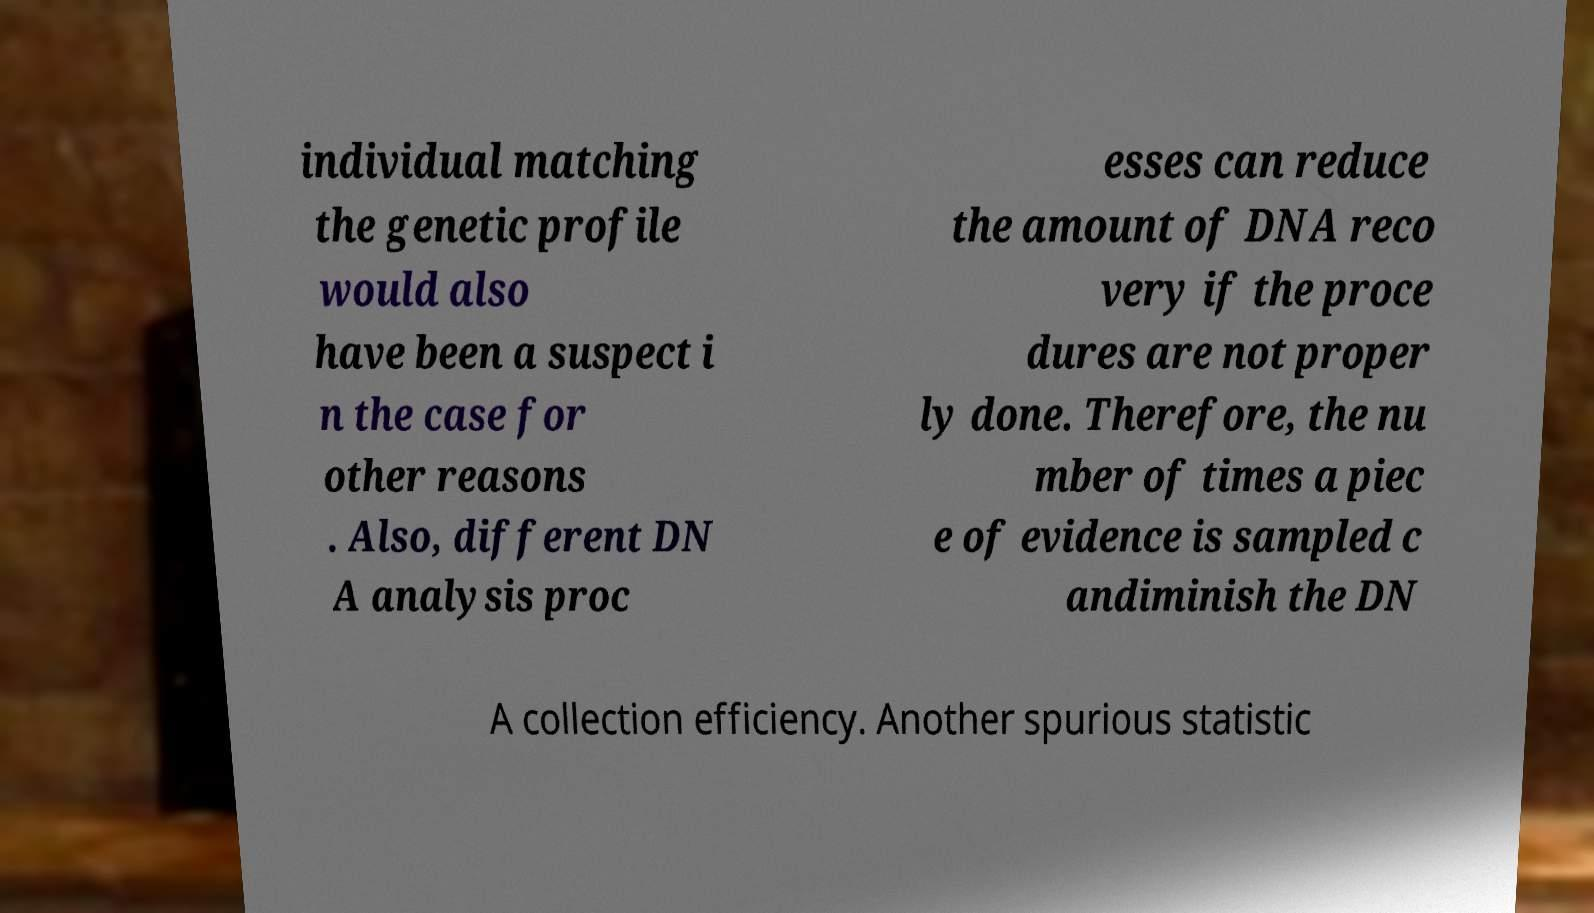I need the written content from this picture converted into text. Can you do that? individual matching the genetic profile would also have been a suspect i n the case for other reasons . Also, different DN A analysis proc esses can reduce the amount of DNA reco very if the proce dures are not proper ly done. Therefore, the nu mber of times a piec e of evidence is sampled c andiminish the DN A collection efficiency. Another spurious statistic 